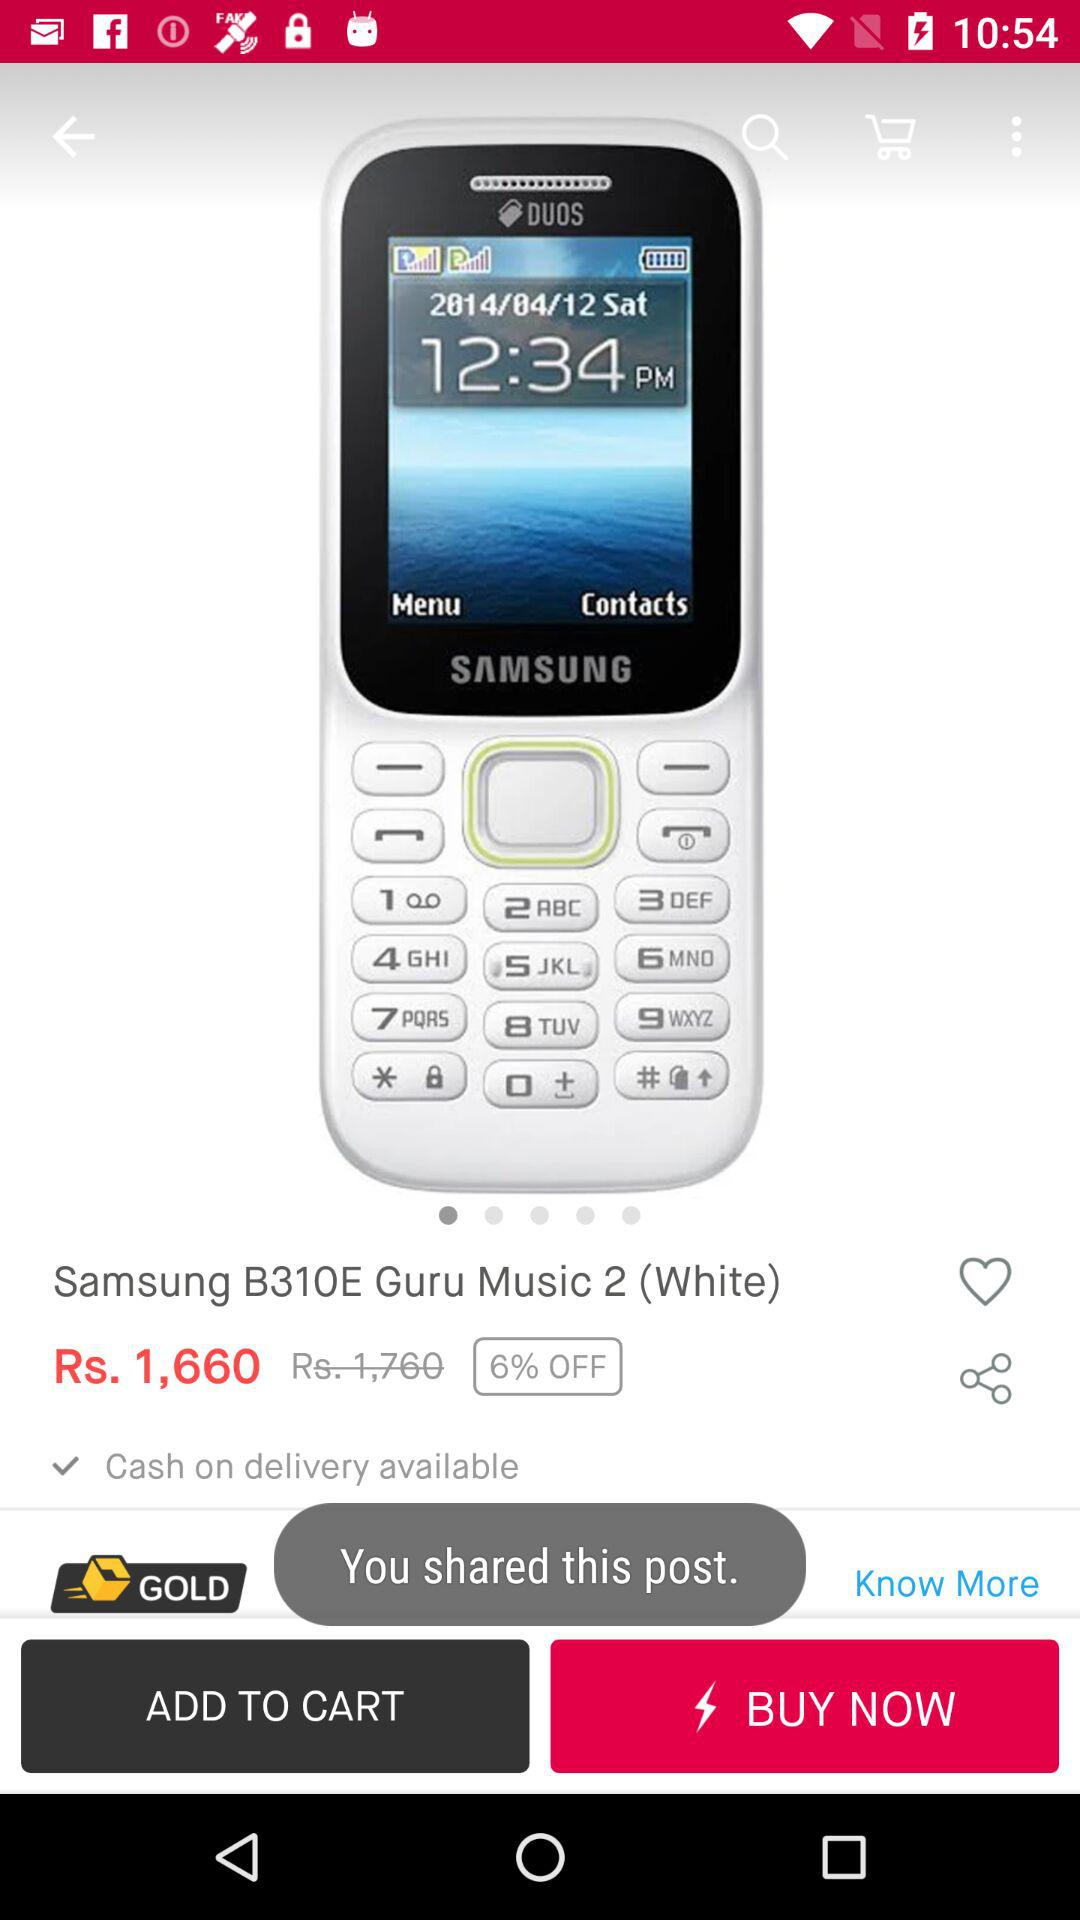How much is the discount on the product?
Answer the question using a single word or phrase. 6% 